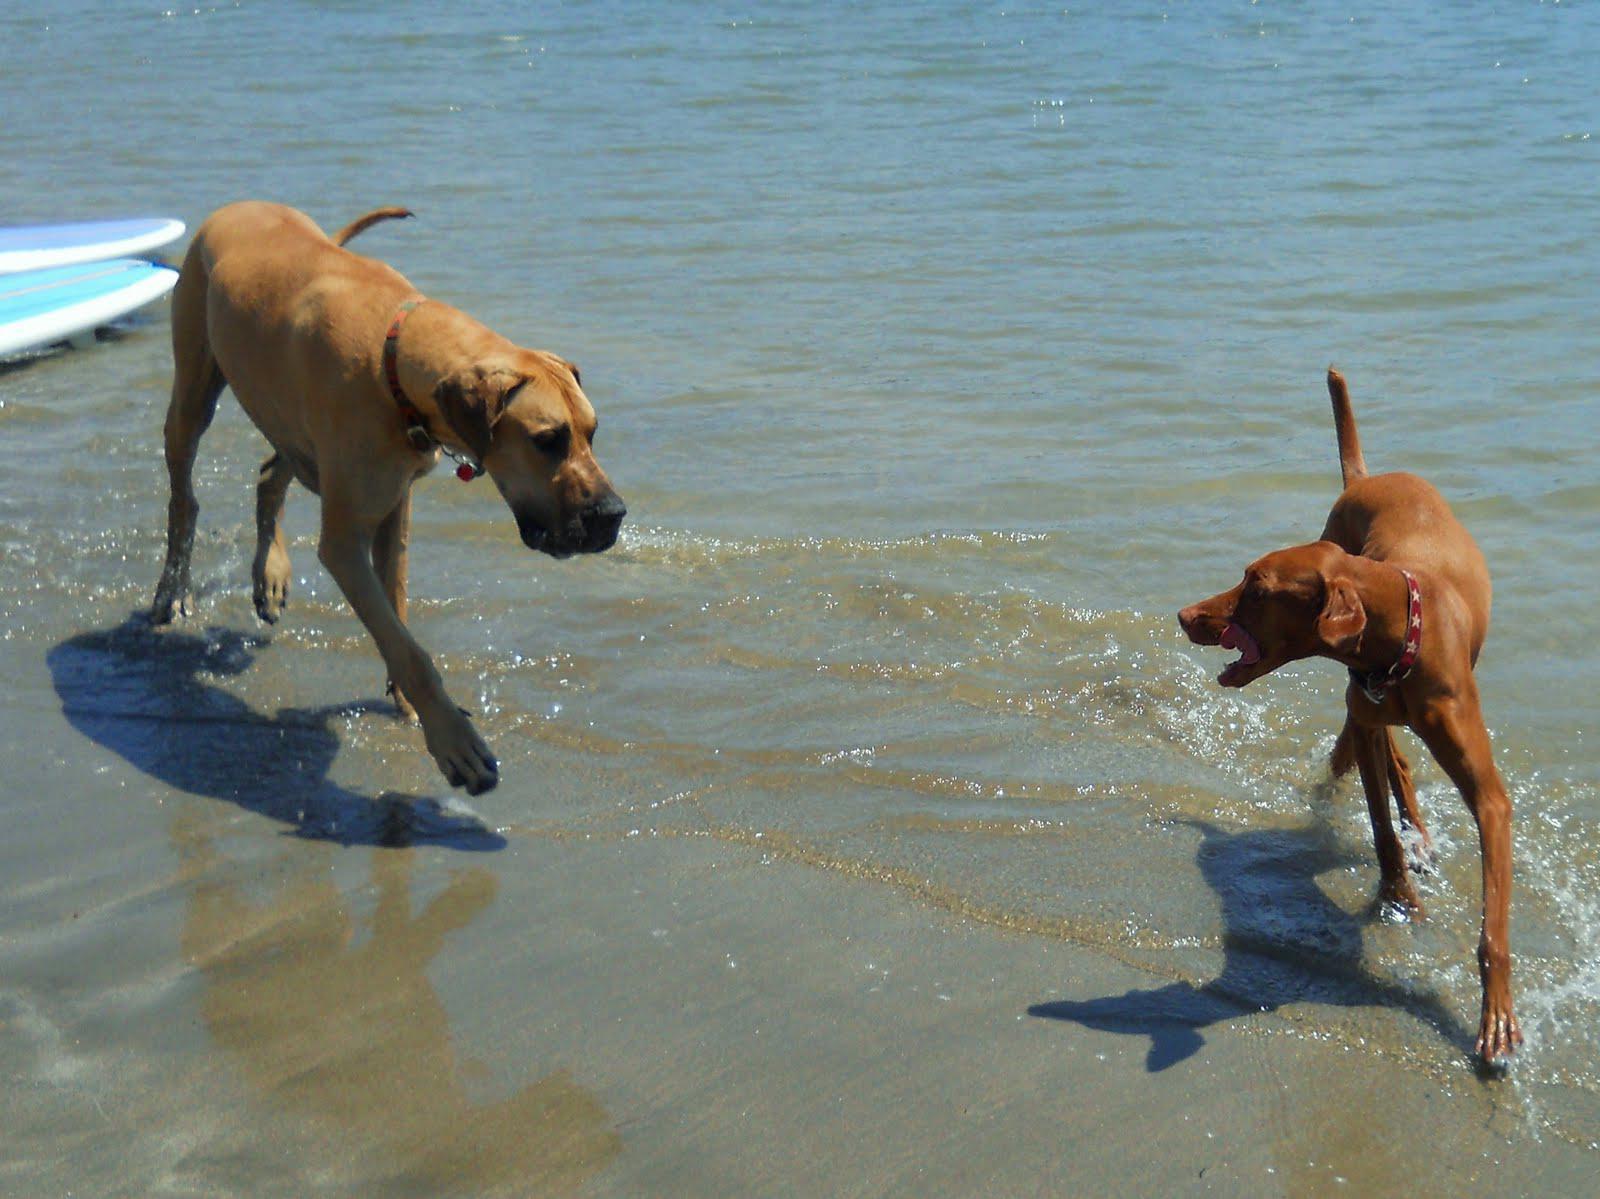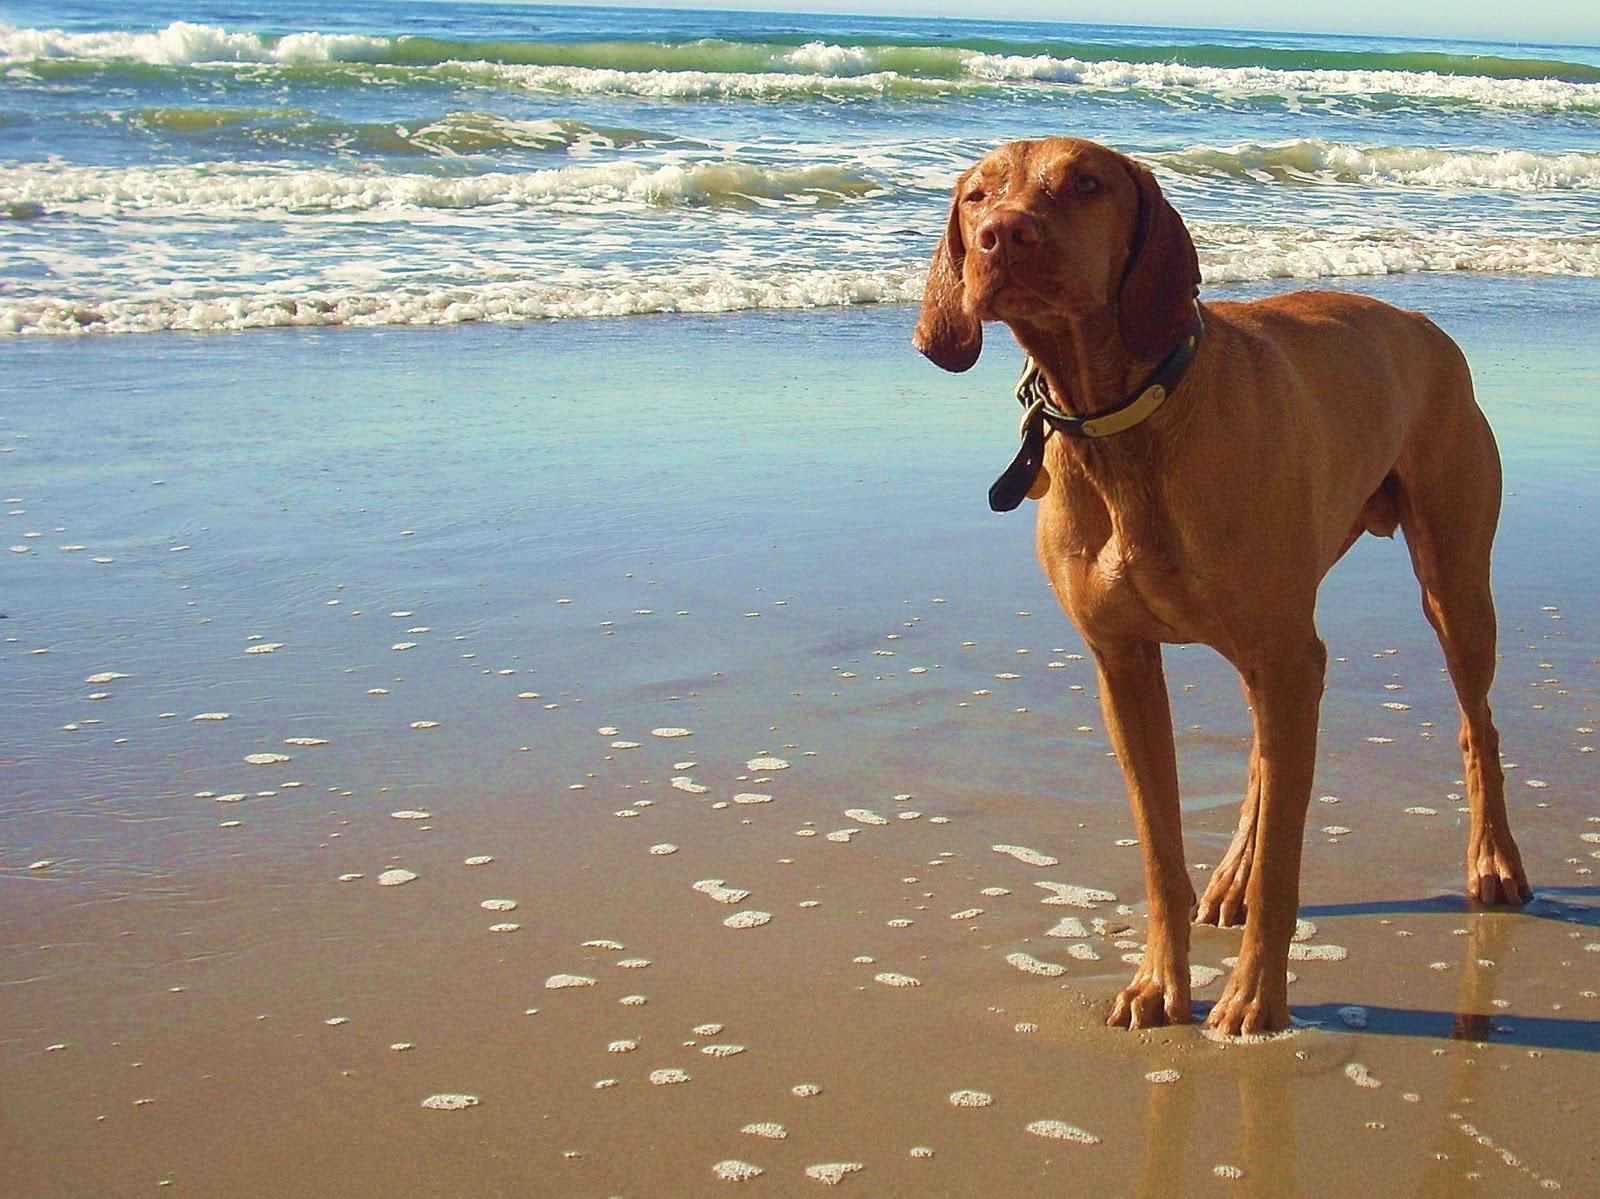The first image is the image on the left, the second image is the image on the right. Analyze the images presented: Is the assertion "There are three dogs in the image pair." valid? Answer yes or no. Yes. The first image is the image on the left, the second image is the image on the right. Given the left and right images, does the statement "The dog in the image on the right is standing on the sand." hold true? Answer yes or no. Yes. 